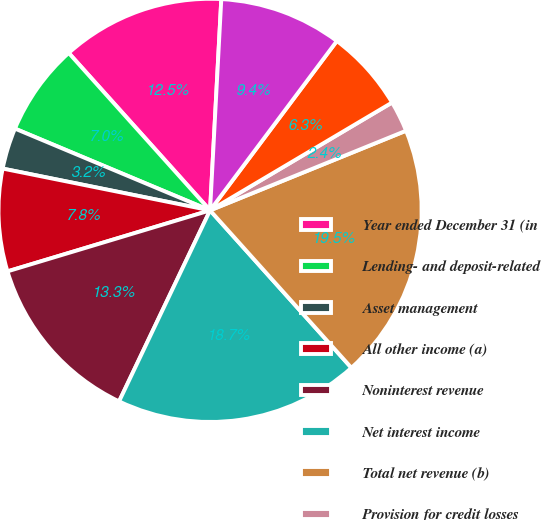Convert chart. <chart><loc_0><loc_0><loc_500><loc_500><pie_chart><fcel>Year ended December 31 (in<fcel>Lending- and deposit-related<fcel>Asset management<fcel>All other income (a)<fcel>Noninterest revenue<fcel>Net interest income<fcel>Total net revenue (b)<fcel>Provision for credit losses<fcel>Compensation expense (c)<fcel>Noncompensation expense (c)<nl><fcel>12.49%<fcel>7.04%<fcel>3.15%<fcel>7.82%<fcel>13.27%<fcel>18.72%<fcel>19.5%<fcel>2.37%<fcel>6.26%<fcel>9.38%<nl></chart> 